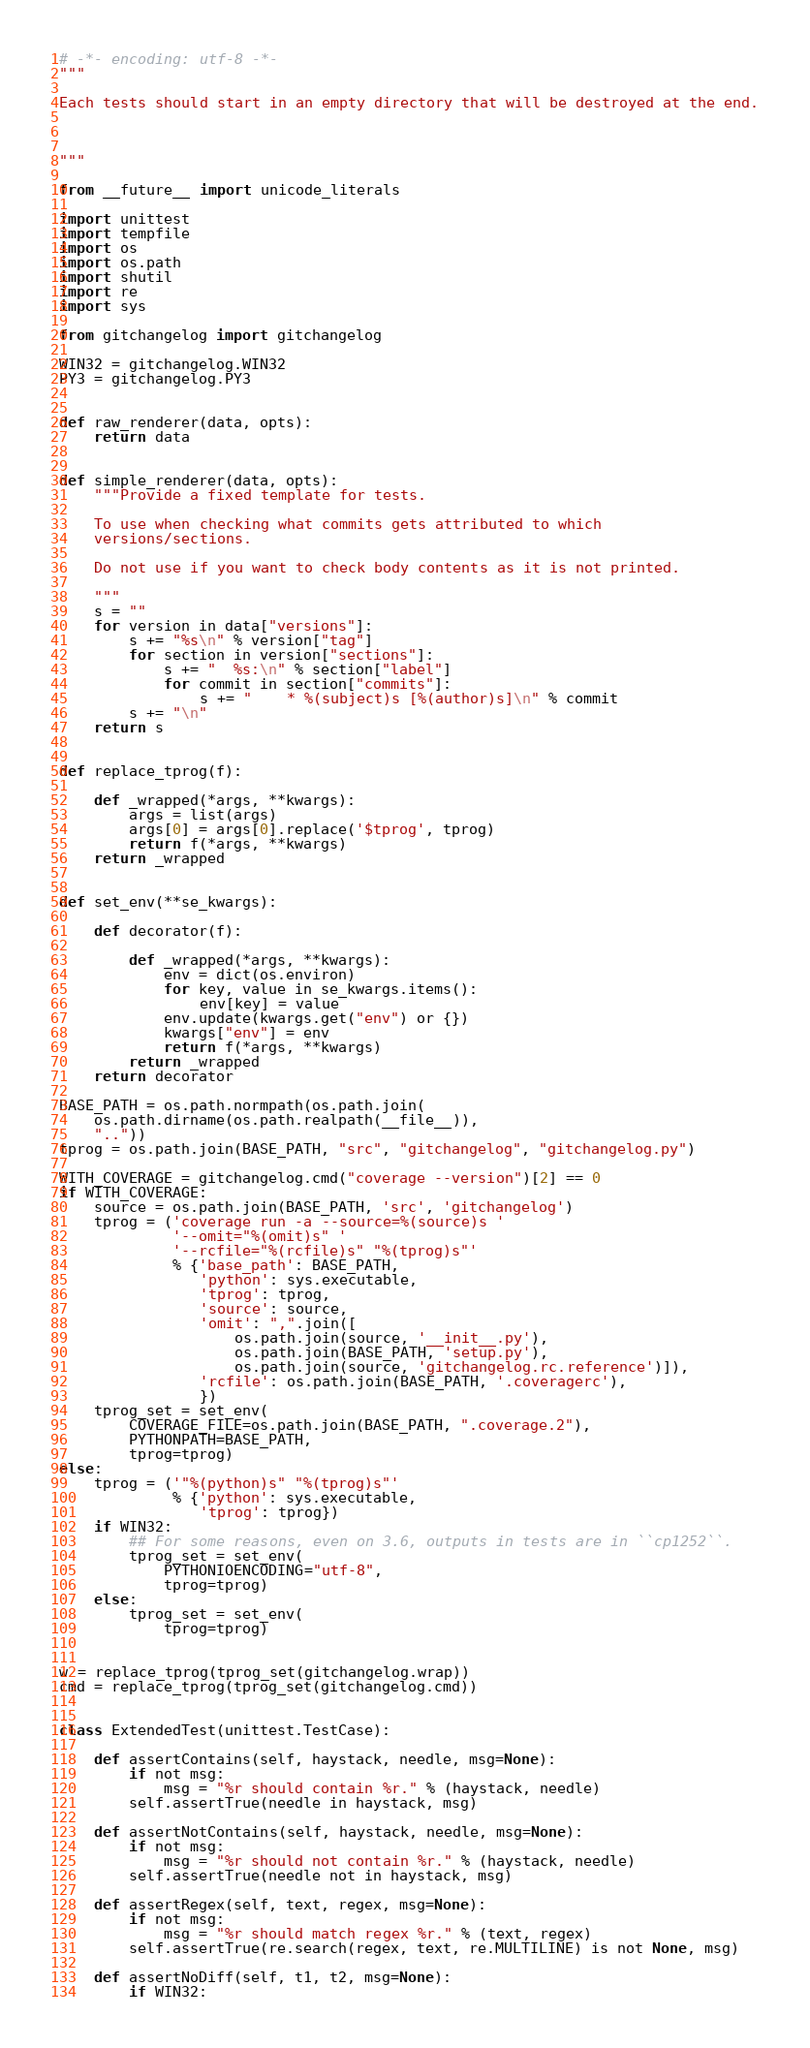<code> <loc_0><loc_0><loc_500><loc_500><_Python_># -*- encoding: utf-8 -*-
"""

Each tests should start in an empty directory that will be destroyed at the end.



"""

from __future__ import unicode_literals

import unittest
import tempfile
import os
import os.path
import shutil
import re
import sys

from gitchangelog import gitchangelog

WIN32 = gitchangelog.WIN32
PY3 = gitchangelog.PY3


def raw_renderer(data, opts):
    return data


def simple_renderer(data, opts):
    """Provide a fixed template for tests.

    To use when checking what commits gets attributed to which
    versions/sections.

    Do not use if you want to check body contents as it is not printed.

    """
    s = ""
    for version in data["versions"]:
        s += "%s\n" % version["tag"]
        for section in version["sections"]:
            s += "  %s:\n" % section["label"]
            for commit in section["commits"]:
                s += "    * %(subject)s [%(author)s]\n" % commit
        s += "\n"
    return s


def replace_tprog(f):

    def _wrapped(*args, **kwargs):
        args = list(args)
        args[0] = args[0].replace('$tprog', tprog)
        return f(*args, **kwargs)
    return _wrapped


def set_env(**se_kwargs):

    def decorator(f):

        def _wrapped(*args, **kwargs):
            env = dict(os.environ)
            for key, value in se_kwargs.items():
                env[key] = value
            env.update(kwargs.get("env") or {})
            kwargs["env"] = env
            return f(*args, **kwargs)
        return _wrapped
    return decorator

BASE_PATH = os.path.normpath(os.path.join(
    os.path.dirname(os.path.realpath(__file__)),
    ".."))
tprog = os.path.join(BASE_PATH, "src", "gitchangelog", "gitchangelog.py")

WITH_COVERAGE = gitchangelog.cmd("coverage --version")[2] == 0
if WITH_COVERAGE:
    source = os.path.join(BASE_PATH, 'src', 'gitchangelog')
    tprog = ('coverage run -a --source=%(source)s '
             '--omit="%(omit)s" '
             '--rcfile="%(rcfile)s" "%(tprog)s"'
             % {'base_path': BASE_PATH,
                'python': sys.executable,
                'tprog': tprog,
                'source': source,
                'omit': ",".join([
                    os.path.join(source, '__init__.py'),
                    os.path.join(BASE_PATH, 'setup.py'),
                    os.path.join(source, 'gitchangelog.rc.reference')]),
                'rcfile': os.path.join(BASE_PATH, '.coveragerc'),
                })
    tprog_set = set_env(
        COVERAGE_FILE=os.path.join(BASE_PATH, ".coverage.2"),
        PYTHONPATH=BASE_PATH,
        tprog=tprog)
else:
    tprog = ('"%(python)s" "%(tprog)s"'
             % {'python': sys.executable,
                'tprog': tprog})
    if WIN32:
        ## For some reasons, even on 3.6, outputs in tests are in ``cp1252``.
        tprog_set = set_env(
            PYTHONIOENCODING="utf-8",
            tprog=tprog)
    else:
        tprog_set = set_env(
            tprog=tprog)


w = replace_tprog(tprog_set(gitchangelog.wrap))
cmd = replace_tprog(tprog_set(gitchangelog.cmd))


class ExtendedTest(unittest.TestCase):

    def assertContains(self, haystack, needle, msg=None):
        if not msg:
            msg = "%r should contain %r." % (haystack, needle)
        self.assertTrue(needle in haystack, msg)

    def assertNotContains(self, haystack, needle, msg=None):
        if not msg:
            msg = "%r should not contain %r." % (haystack, needle)
        self.assertTrue(needle not in haystack, msg)

    def assertRegex(self, text, regex, msg=None):
        if not msg:
            msg = "%r should match regex %r." % (text, regex)
        self.assertTrue(re.search(regex, text, re.MULTILINE) is not None, msg)

    def assertNoDiff(self, t1, t2, msg=None):
        if WIN32:</code> 